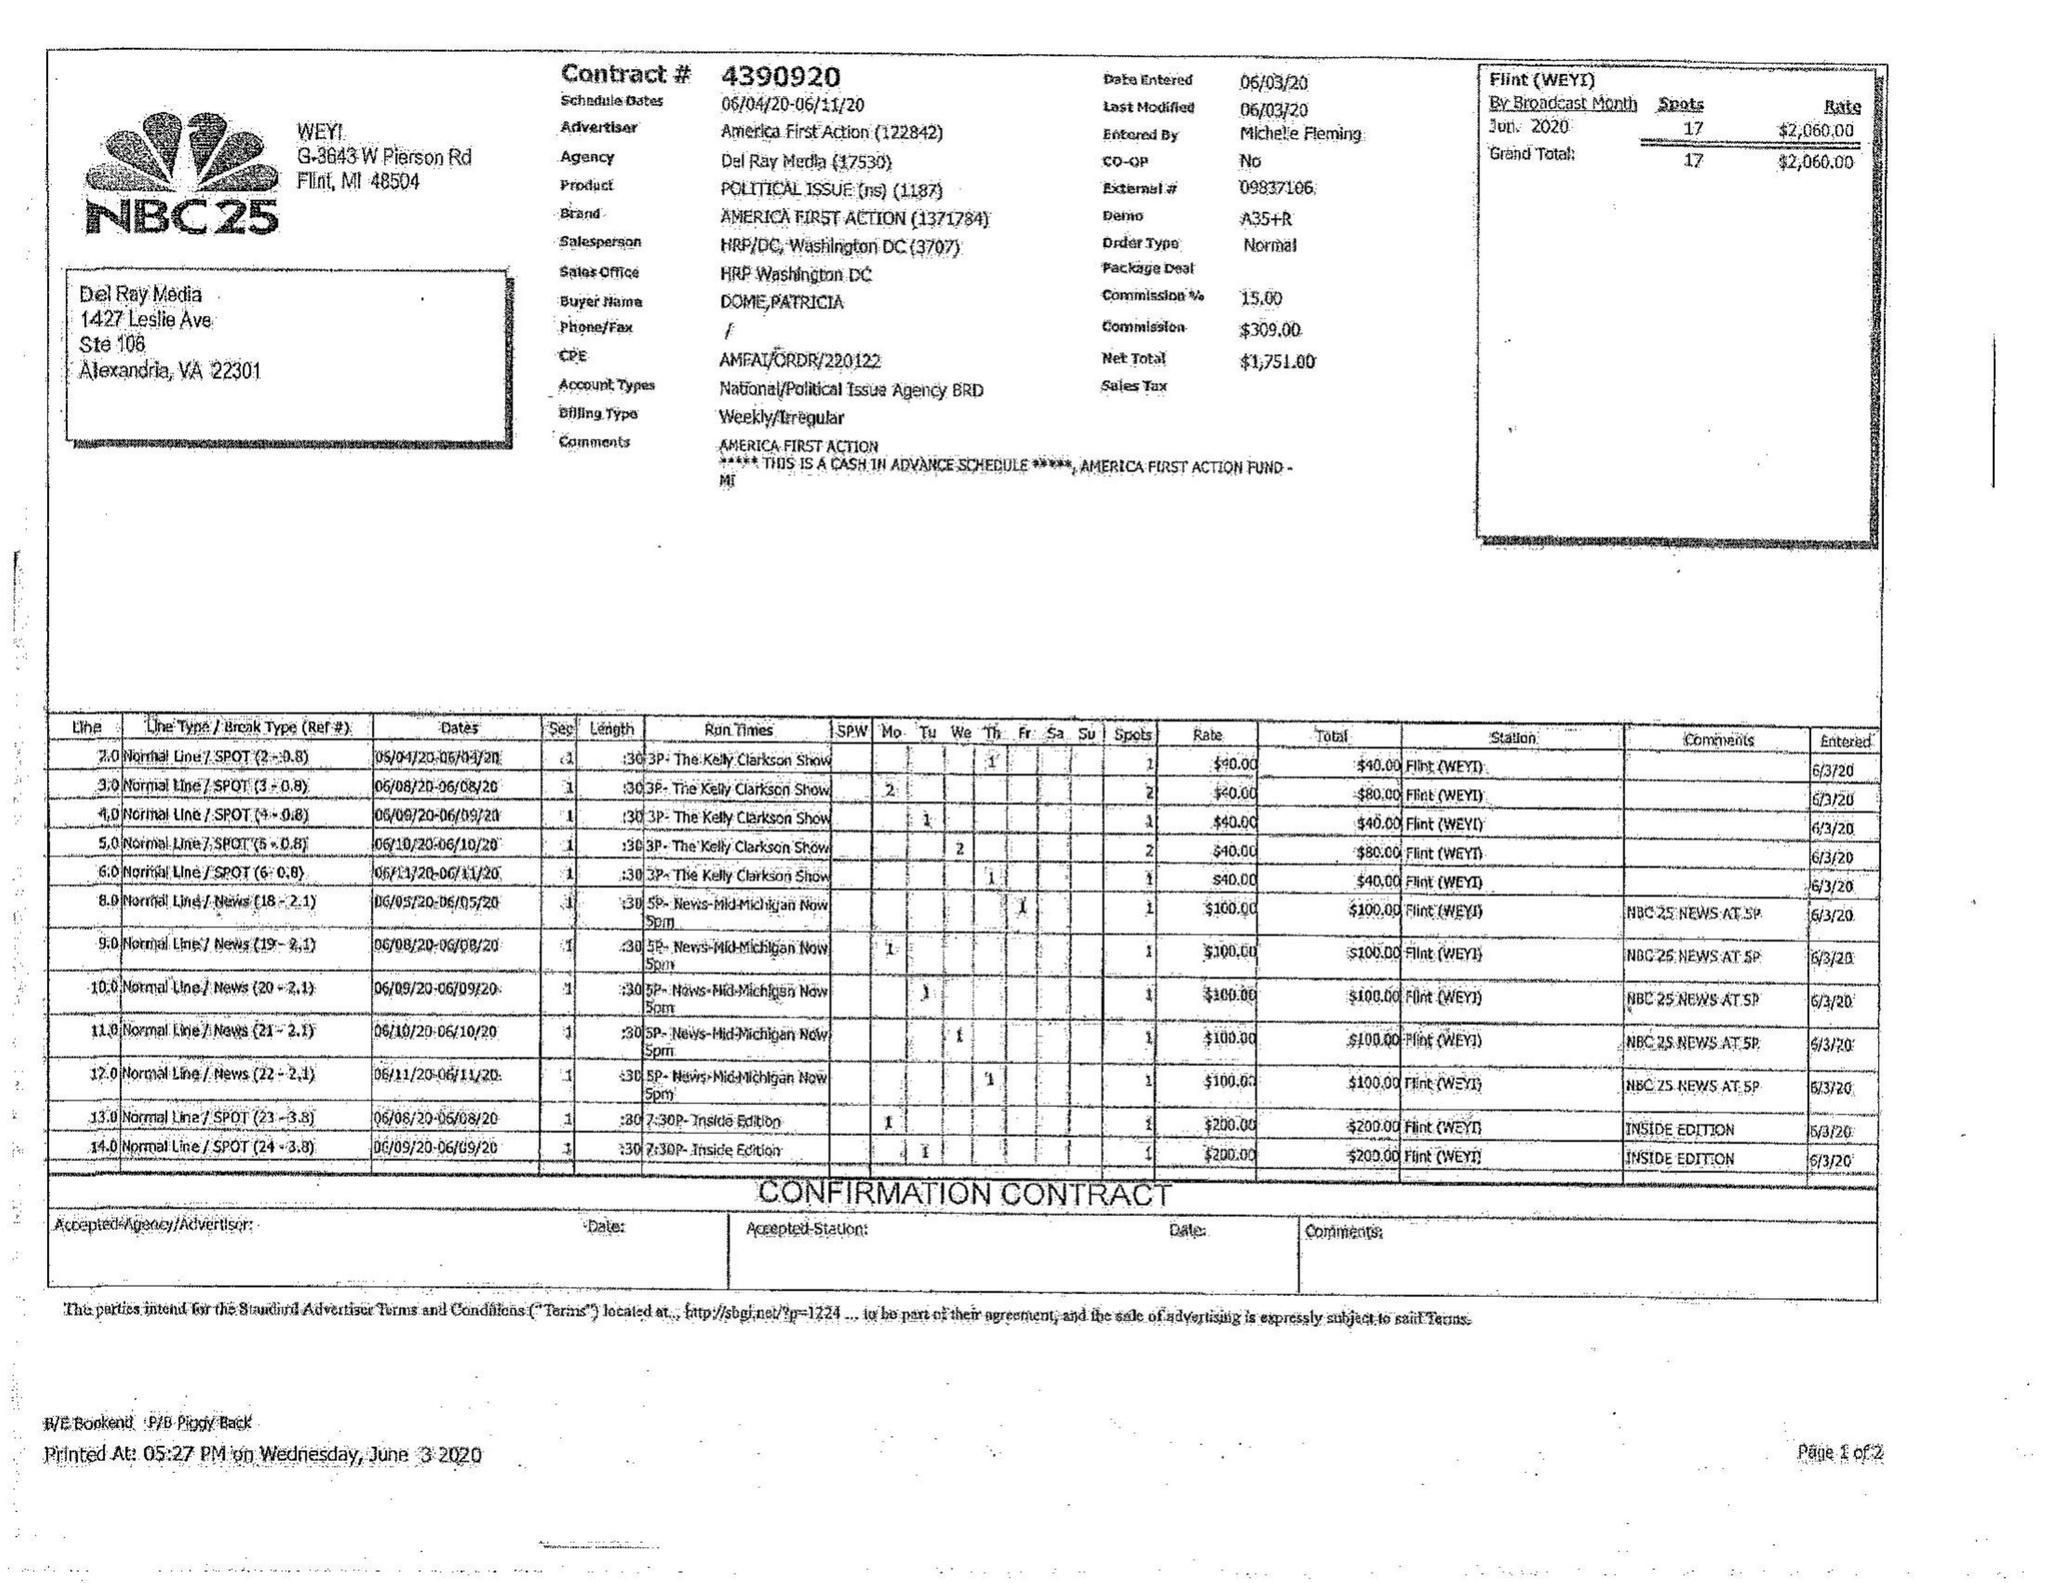What is the value for the flight_to?
Answer the question using a single word or phrase. 06/11/20 